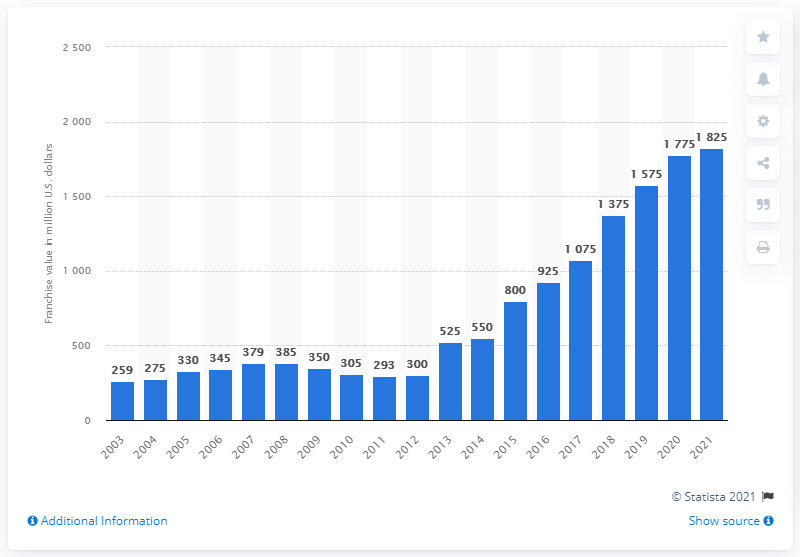Draw attention to some important aspects in this diagram. The estimated value of the Sacramento Kings in 2021 was approximately 1825. 